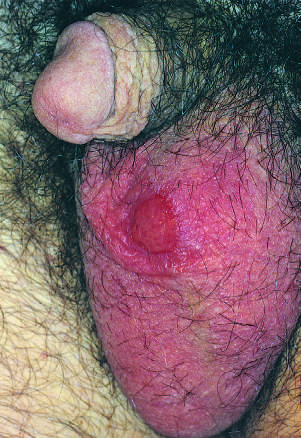how are such lesions?
Answer the question using a single word or phrase. Painless despite the presence of ulceration 